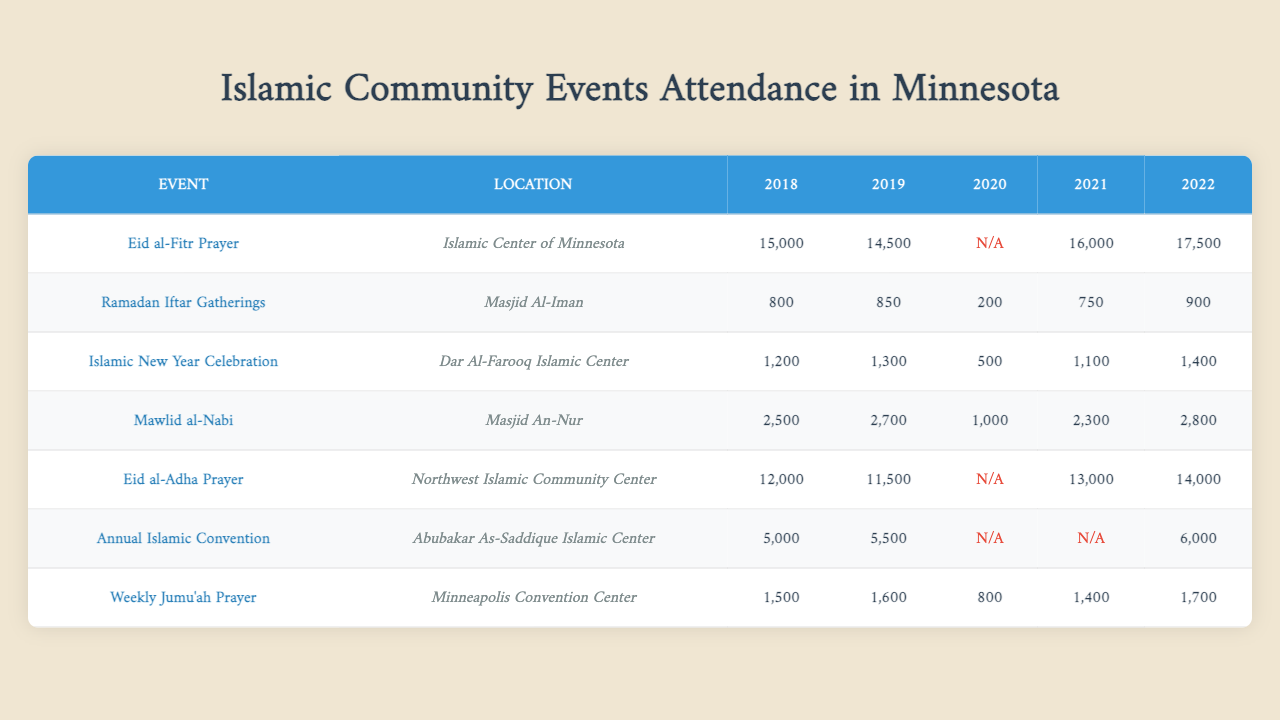What is the attendance for the Eid al-Fitr Prayer in 2022? The table shows the attendance for the Eid al-Fitr Prayer at the Islamic Center of Minnesota for the year 2022, which is 17,500.
Answer: 17,500 Which event had the highest attendance in 2019? By comparing the attendance data for all events in 2019, the Eid al-Fitr Prayer recorded the highest attendance of 14,500.
Answer: Eid al-Fitr Prayer Was there an Islamic New Year Celebration held in 2020? The table indicates that the attendance for the Islamic New Year Celebration in 2020 is 500, which confirms that the event occurred that year.
Answer: Yes How does the attendance for Ramadan Iftar Gatherings in 2021 compare to 2018? The attendance for Ramadan Iftar Gatherings in 2021 is 750, while in 2018, it was 800. This shows a decrease of 50 attendees.
Answer: Decrease of 50 What is the average attendance for Eid al-Adha Prayer from 2018 to 2022? The attendance for Eid al-Adha Prayer over the years is 12,000 (2018), 11,500 (2019), 0 (2020), 13,000 (2021), and 14,000 (2022). Ignoring the year with zero attendance, the sum is: 12,000 + 11,500 + 13,000 + 14,000 = 50,500. There are 4 years with valid data, so the average is 50,500 / 4 = 12,625.
Answer: 12,625 How many events had attendance over 2,500 in 2022? Looking at the attendance data for 2022, the Eid al-Fitr Prayer (17,500), Eid al-Adha Prayer (14,000), and Mawlid al-Nabi (2,800) exceed 2,500. That totals three events with such attendance.
Answer: 3 Which event had the lowest attendance in 2020? Referring to the data for 2020, the only attendance recorded is 0 for the Eid al-Fitr Prayer and the Annual Islamic Convention. When looking for the event with the lowest attendance that actually occurred, the Islamic New Year Celebration with 500 is the answer.
Answer: Islamic New Year Celebration What was the overall attendance trend for Weekly Jumu'ah Prayer from 2018 to 2022? The attendance for Weekly Jumu'ah Prayer shows values of 1,500 (2018), 1,600 (2019), 800 (2020), 1,400 (2021), and 1,700 (2022). Comparing these values, the attendance increased from 2018 to 2019, decreased in 2020, then increased again in 2021 and 2022, indicating a fluctuating trend over the years.
Answer: Fluctuating trend In which year did the Annual Islamic Convention have zero attendance? The data shows a zero attendance for the Annual Islamic Convention specifically for the years 2020 and 2021. Therefore, both years are correct.
Answer: 2020 and 2021 What is the difference in attendance for the Eid al-Fitr Prayer between 2018 and 2021? The attendance for Eid al-Fitr Prayer in 2018 is 15,000, while in 2021 it is 16,000. To find the difference: 16,000 - 15,000 = 1,000. This indicates an increase of 1,000 attendees from 2018 to 2021.
Answer: 1,000 